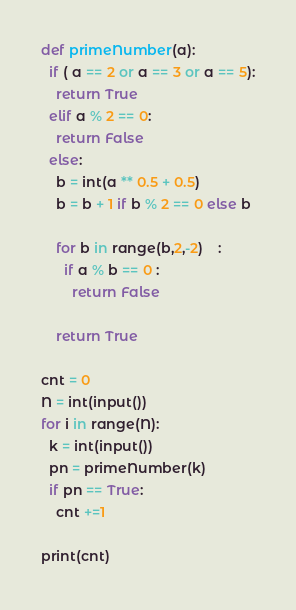Convert code to text. <code><loc_0><loc_0><loc_500><loc_500><_Python_>def primeNumber(a):
  if ( a == 2 or a == 3 or a == 5):
    return True
  elif a % 2 == 0:
    return False
  else:
    b = int(a ** 0.5 + 0.5)
    b = b + 1 if b % 2 == 0 else b

    for b in range(b,2,-2)	:
      if a % b == 0 :
        return False

    return True

cnt = 0
N = int(input())
for i in range(N):
  k = int(input())
  pn = primeNumber(k)
  if pn == True:
    cnt +=1
    
print(cnt)
</code> 